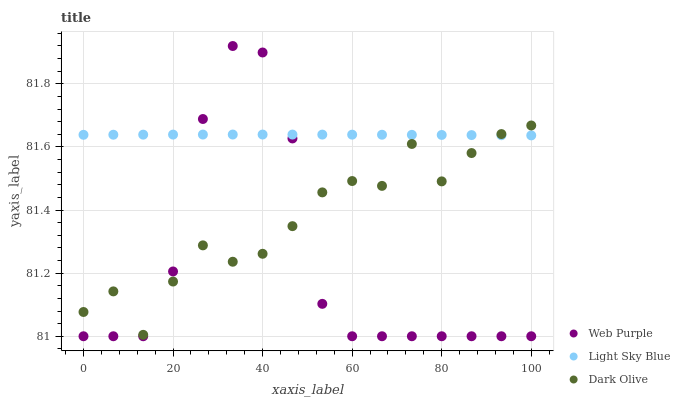Does Web Purple have the minimum area under the curve?
Answer yes or no. Yes. Does Light Sky Blue have the maximum area under the curve?
Answer yes or no. Yes. Does Light Sky Blue have the minimum area under the curve?
Answer yes or no. No. Does Web Purple have the maximum area under the curve?
Answer yes or no. No. Is Light Sky Blue the smoothest?
Answer yes or no. Yes. Is Web Purple the roughest?
Answer yes or no. Yes. Is Web Purple the smoothest?
Answer yes or no. No. Is Light Sky Blue the roughest?
Answer yes or no. No. Does Web Purple have the lowest value?
Answer yes or no. Yes. Does Light Sky Blue have the lowest value?
Answer yes or no. No. Does Web Purple have the highest value?
Answer yes or no. Yes. Does Light Sky Blue have the highest value?
Answer yes or no. No. Does Light Sky Blue intersect Web Purple?
Answer yes or no. Yes. Is Light Sky Blue less than Web Purple?
Answer yes or no. No. Is Light Sky Blue greater than Web Purple?
Answer yes or no. No. 